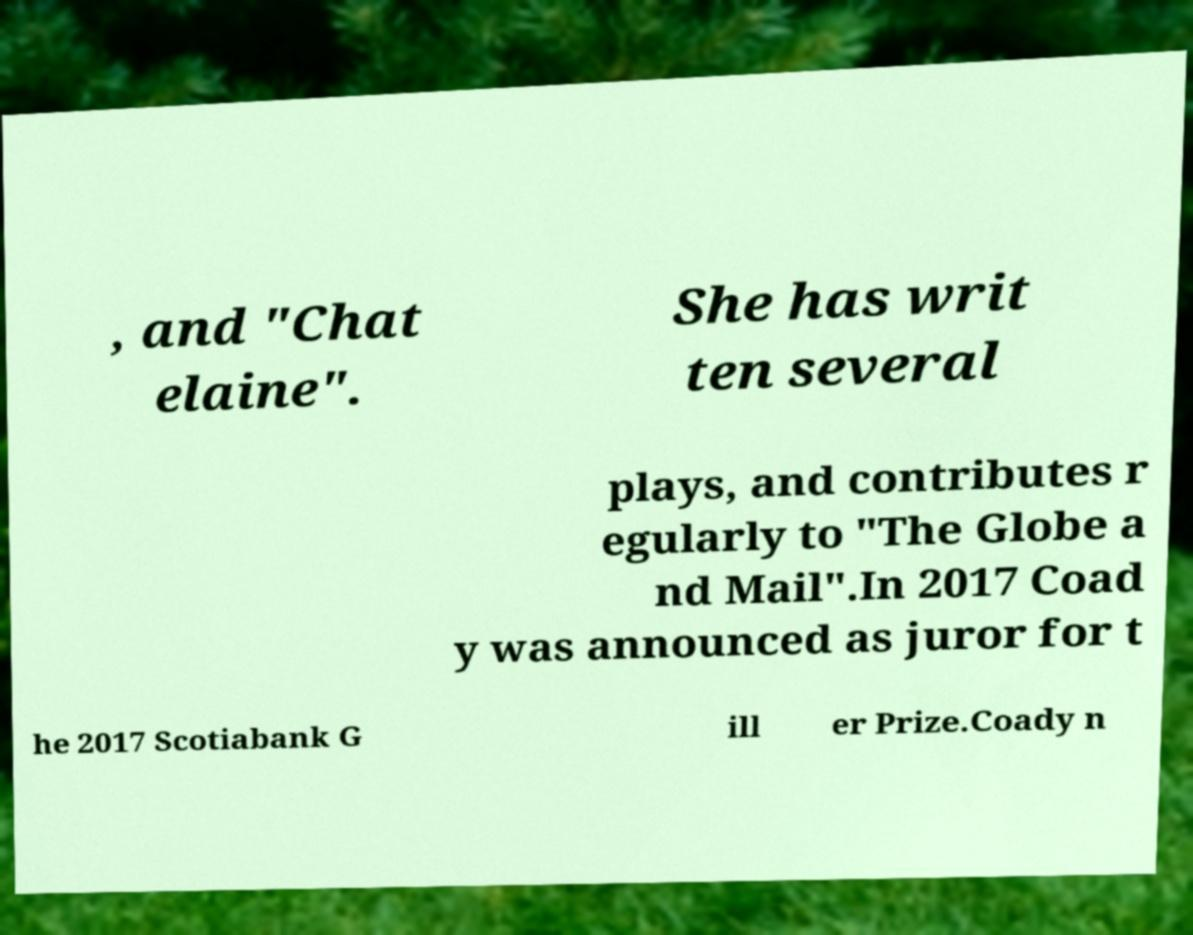Could you assist in decoding the text presented in this image and type it out clearly? , and "Chat elaine". She has writ ten several plays, and contributes r egularly to "The Globe a nd Mail".In 2017 Coad y was announced as juror for t he 2017 Scotiabank G ill er Prize.Coady n 